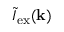Convert formula to latex. <formula><loc_0><loc_0><loc_500><loc_500>\tilde { I } _ { e x } ( k )</formula> 